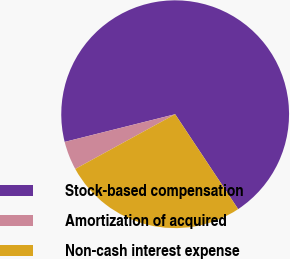Convert chart. <chart><loc_0><loc_0><loc_500><loc_500><pie_chart><fcel>Stock-based compensation<fcel>Amortization of acquired<fcel>Non-cash interest expense<nl><fcel>69.58%<fcel>4.07%<fcel>26.35%<nl></chart> 